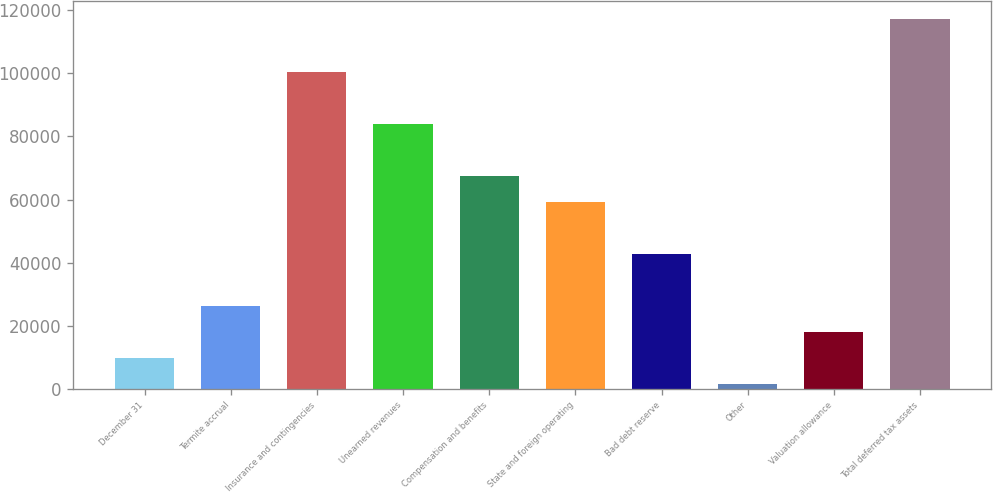<chart> <loc_0><loc_0><loc_500><loc_500><bar_chart><fcel>December 31<fcel>Termite accrual<fcel>Insurance and contingencies<fcel>Unearned revenues<fcel>Compensation and benefits<fcel>State and foreign operating<fcel>Bad debt reserve<fcel>Other<fcel>Valuation allowance<fcel>Total deferred tax assets<nl><fcel>9651.4<fcel>26186.2<fcel>100593<fcel>84058<fcel>67523.2<fcel>59255.8<fcel>42721<fcel>1384<fcel>17918.8<fcel>117128<nl></chart> 